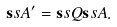<formula> <loc_0><loc_0><loc_500><loc_500>\mathbf s s { A } ^ { \prime } = \mathbf s s { Q } \mathbf s s { A } .</formula> 